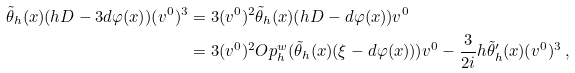<formula> <loc_0><loc_0><loc_500><loc_500>\tilde { \theta } _ { h } ( x ) ( h D - 3 d \varphi ( x ) ) ( v ^ { 0 } ) ^ { 3 } & = 3 ( v ^ { 0 } ) ^ { 2 } \tilde { \theta } _ { h } ( x ) ( h D - d \varphi ( x ) ) v ^ { 0 } \\ & = 3 ( v ^ { 0 } ) ^ { 2 } O p _ { h } ^ { w } ( \tilde { \theta } _ { h } ( x ) ( \xi - d \varphi ( x ) ) ) v ^ { 0 } - \frac { 3 } { 2 i } h \tilde { \theta } ^ { \prime } _ { h } ( x ) ( v ^ { 0 } ) ^ { 3 } \, ,</formula> 